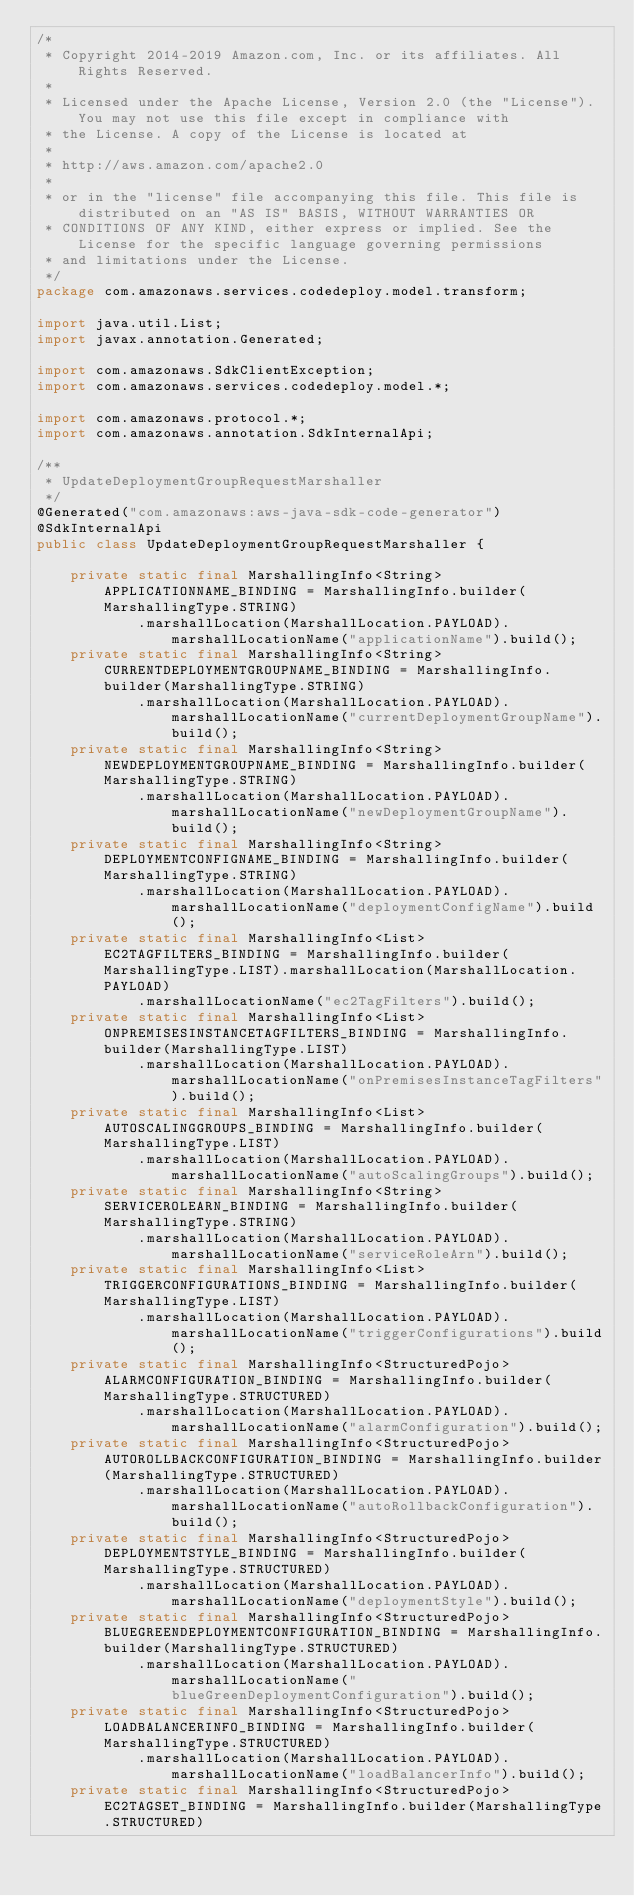Convert code to text. <code><loc_0><loc_0><loc_500><loc_500><_Java_>/*
 * Copyright 2014-2019 Amazon.com, Inc. or its affiliates. All Rights Reserved.
 * 
 * Licensed under the Apache License, Version 2.0 (the "License"). You may not use this file except in compliance with
 * the License. A copy of the License is located at
 * 
 * http://aws.amazon.com/apache2.0
 * 
 * or in the "license" file accompanying this file. This file is distributed on an "AS IS" BASIS, WITHOUT WARRANTIES OR
 * CONDITIONS OF ANY KIND, either express or implied. See the License for the specific language governing permissions
 * and limitations under the License.
 */
package com.amazonaws.services.codedeploy.model.transform;

import java.util.List;
import javax.annotation.Generated;

import com.amazonaws.SdkClientException;
import com.amazonaws.services.codedeploy.model.*;

import com.amazonaws.protocol.*;
import com.amazonaws.annotation.SdkInternalApi;

/**
 * UpdateDeploymentGroupRequestMarshaller
 */
@Generated("com.amazonaws:aws-java-sdk-code-generator")
@SdkInternalApi
public class UpdateDeploymentGroupRequestMarshaller {

    private static final MarshallingInfo<String> APPLICATIONNAME_BINDING = MarshallingInfo.builder(MarshallingType.STRING)
            .marshallLocation(MarshallLocation.PAYLOAD).marshallLocationName("applicationName").build();
    private static final MarshallingInfo<String> CURRENTDEPLOYMENTGROUPNAME_BINDING = MarshallingInfo.builder(MarshallingType.STRING)
            .marshallLocation(MarshallLocation.PAYLOAD).marshallLocationName("currentDeploymentGroupName").build();
    private static final MarshallingInfo<String> NEWDEPLOYMENTGROUPNAME_BINDING = MarshallingInfo.builder(MarshallingType.STRING)
            .marshallLocation(MarshallLocation.PAYLOAD).marshallLocationName("newDeploymentGroupName").build();
    private static final MarshallingInfo<String> DEPLOYMENTCONFIGNAME_BINDING = MarshallingInfo.builder(MarshallingType.STRING)
            .marshallLocation(MarshallLocation.PAYLOAD).marshallLocationName("deploymentConfigName").build();
    private static final MarshallingInfo<List> EC2TAGFILTERS_BINDING = MarshallingInfo.builder(MarshallingType.LIST).marshallLocation(MarshallLocation.PAYLOAD)
            .marshallLocationName("ec2TagFilters").build();
    private static final MarshallingInfo<List> ONPREMISESINSTANCETAGFILTERS_BINDING = MarshallingInfo.builder(MarshallingType.LIST)
            .marshallLocation(MarshallLocation.PAYLOAD).marshallLocationName("onPremisesInstanceTagFilters").build();
    private static final MarshallingInfo<List> AUTOSCALINGGROUPS_BINDING = MarshallingInfo.builder(MarshallingType.LIST)
            .marshallLocation(MarshallLocation.PAYLOAD).marshallLocationName("autoScalingGroups").build();
    private static final MarshallingInfo<String> SERVICEROLEARN_BINDING = MarshallingInfo.builder(MarshallingType.STRING)
            .marshallLocation(MarshallLocation.PAYLOAD).marshallLocationName("serviceRoleArn").build();
    private static final MarshallingInfo<List> TRIGGERCONFIGURATIONS_BINDING = MarshallingInfo.builder(MarshallingType.LIST)
            .marshallLocation(MarshallLocation.PAYLOAD).marshallLocationName("triggerConfigurations").build();
    private static final MarshallingInfo<StructuredPojo> ALARMCONFIGURATION_BINDING = MarshallingInfo.builder(MarshallingType.STRUCTURED)
            .marshallLocation(MarshallLocation.PAYLOAD).marshallLocationName("alarmConfiguration").build();
    private static final MarshallingInfo<StructuredPojo> AUTOROLLBACKCONFIGURATION_BINDING = MarshallingInfo.builder(MarshallingType.STRUCTURED)
            .marshallLocation(MarshallLocation.PAYLOAD).marshallLocationName("autoRollbackConfiguration").build();
    private static final MarshallingInfo<StructuredPojo> DEPLOYMENTSTYLE_BINDING = MarshallingInfo.builder(MarshallingType.STRUCTURED)
            .marshallLocation(MarshallLocation.PAYLOAD).marshallLocationName("deploymentStyle").build();
    private static final MarshallingInfo<StructuredPojo> BLUEGREENDEPLOYMENTCONFIGURATION_BINDING = MarshallingInfo.builder(MarshallingType.STRUCTURED)
            .marshallLocation(MarshallLocation.PAYLOAD).marshallLocationName("blueGreenDeploymentConfiguration").build();
    private static final MarshallingInfo<StructuredPojo> LOADBALANCERINFO_BINDING = MarshallingInfo.builder(MarshallingType.STRUCTURED)
            .marshallLocation(MarshallLocation.PAYLOAD).marshallLocationName("loadBalancerInfo").build();
    private static final MarshallingInfo<StructuredPojo> EC2TAGSET_BINDING = MarshallingInfo.builder(MarshallingType.STRUCTURED)</code> 